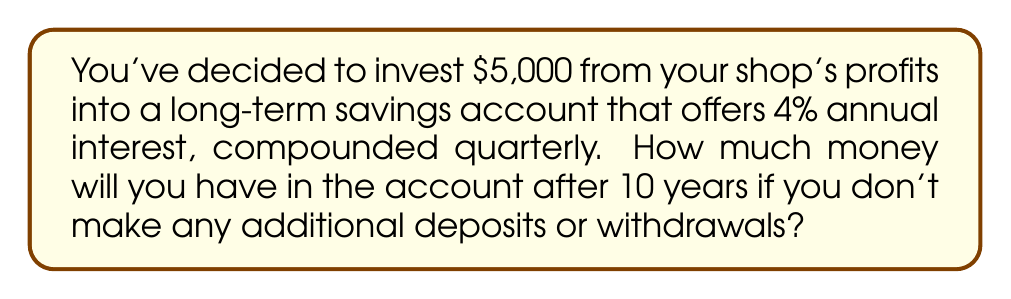Teach me how to tackle this problem. To solve this problem, we'll use the compound interest formula:

$$A = P(1 + \frac{r}{n})^{nt}$$

Where:
$A$ = Final amount
$P$ = Principal (initial investment)
$r$ = Annual interest rate (as a decimal)
$n$ = Number of times interest is compounded per year
$t$ = Number of years

Given:
$P = \$5,000$
$r = 0.04$ (4% expressed as a decimal)
$n = 4$ (compounded quarterly, so 4 times per year)
$t = 10$ years

Let's substitute these values into the formula:

$$A = 5000(1 + \frac{0.04}{4})^{4 \times 10}$$

$$A = 5000(1 + 0.01)^{40}$$

$$A = 5000(1.01)^{40}$$

Using a calculator to evaluate this expression:

$$A = 5000 \times 1.4889390519$$

$$A = 7444.69526$$

Rounding to the nearest cent:

$$A = \$7,444.70$$
Answer: $7,444.70 